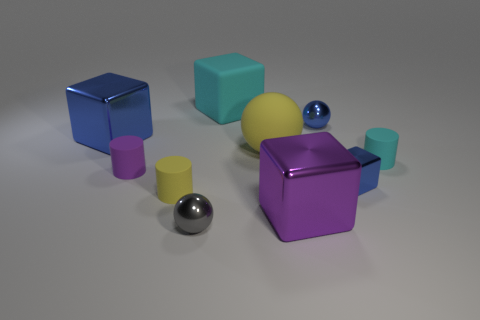What number of small objects have the same material as the blue ball?
Offer a very short reply. 2. There is a cyan object that is behind the blue metal thing that is to the left of the small metal sphere behind the gray metal thing; what is its material?
Provide a short and direct response. Rubber. The shiny sphere in front of the shiny cube that is behind the small cyan cylinder is what color?
Provide a succinct answer. Gray. The metallic block that is the same size as the purple cylinder is what color?
Make the answer very short. Blue. How many large objects are either yellow balls or brown balls?
Your answer should be very brief. 1. Are there more tiny blue metal objects on the left side of the tiny blue ball than blue things that are in front of the tiny gray metal thing?
Keep it short and to the point. No. There is another block that is the same color as the small shiny cube; what is its size?
Your answer should be very brief. Large. How many other things are the same size as the matte sphere?
Offer a very short reply. 3. Is the large yellow thing that is to the right of the purple cylinder made of the same material as the gray object?
Your answer should be compact. No. How many other things are the same color as the matte sphere?
Your answer should be very brief. 1. 